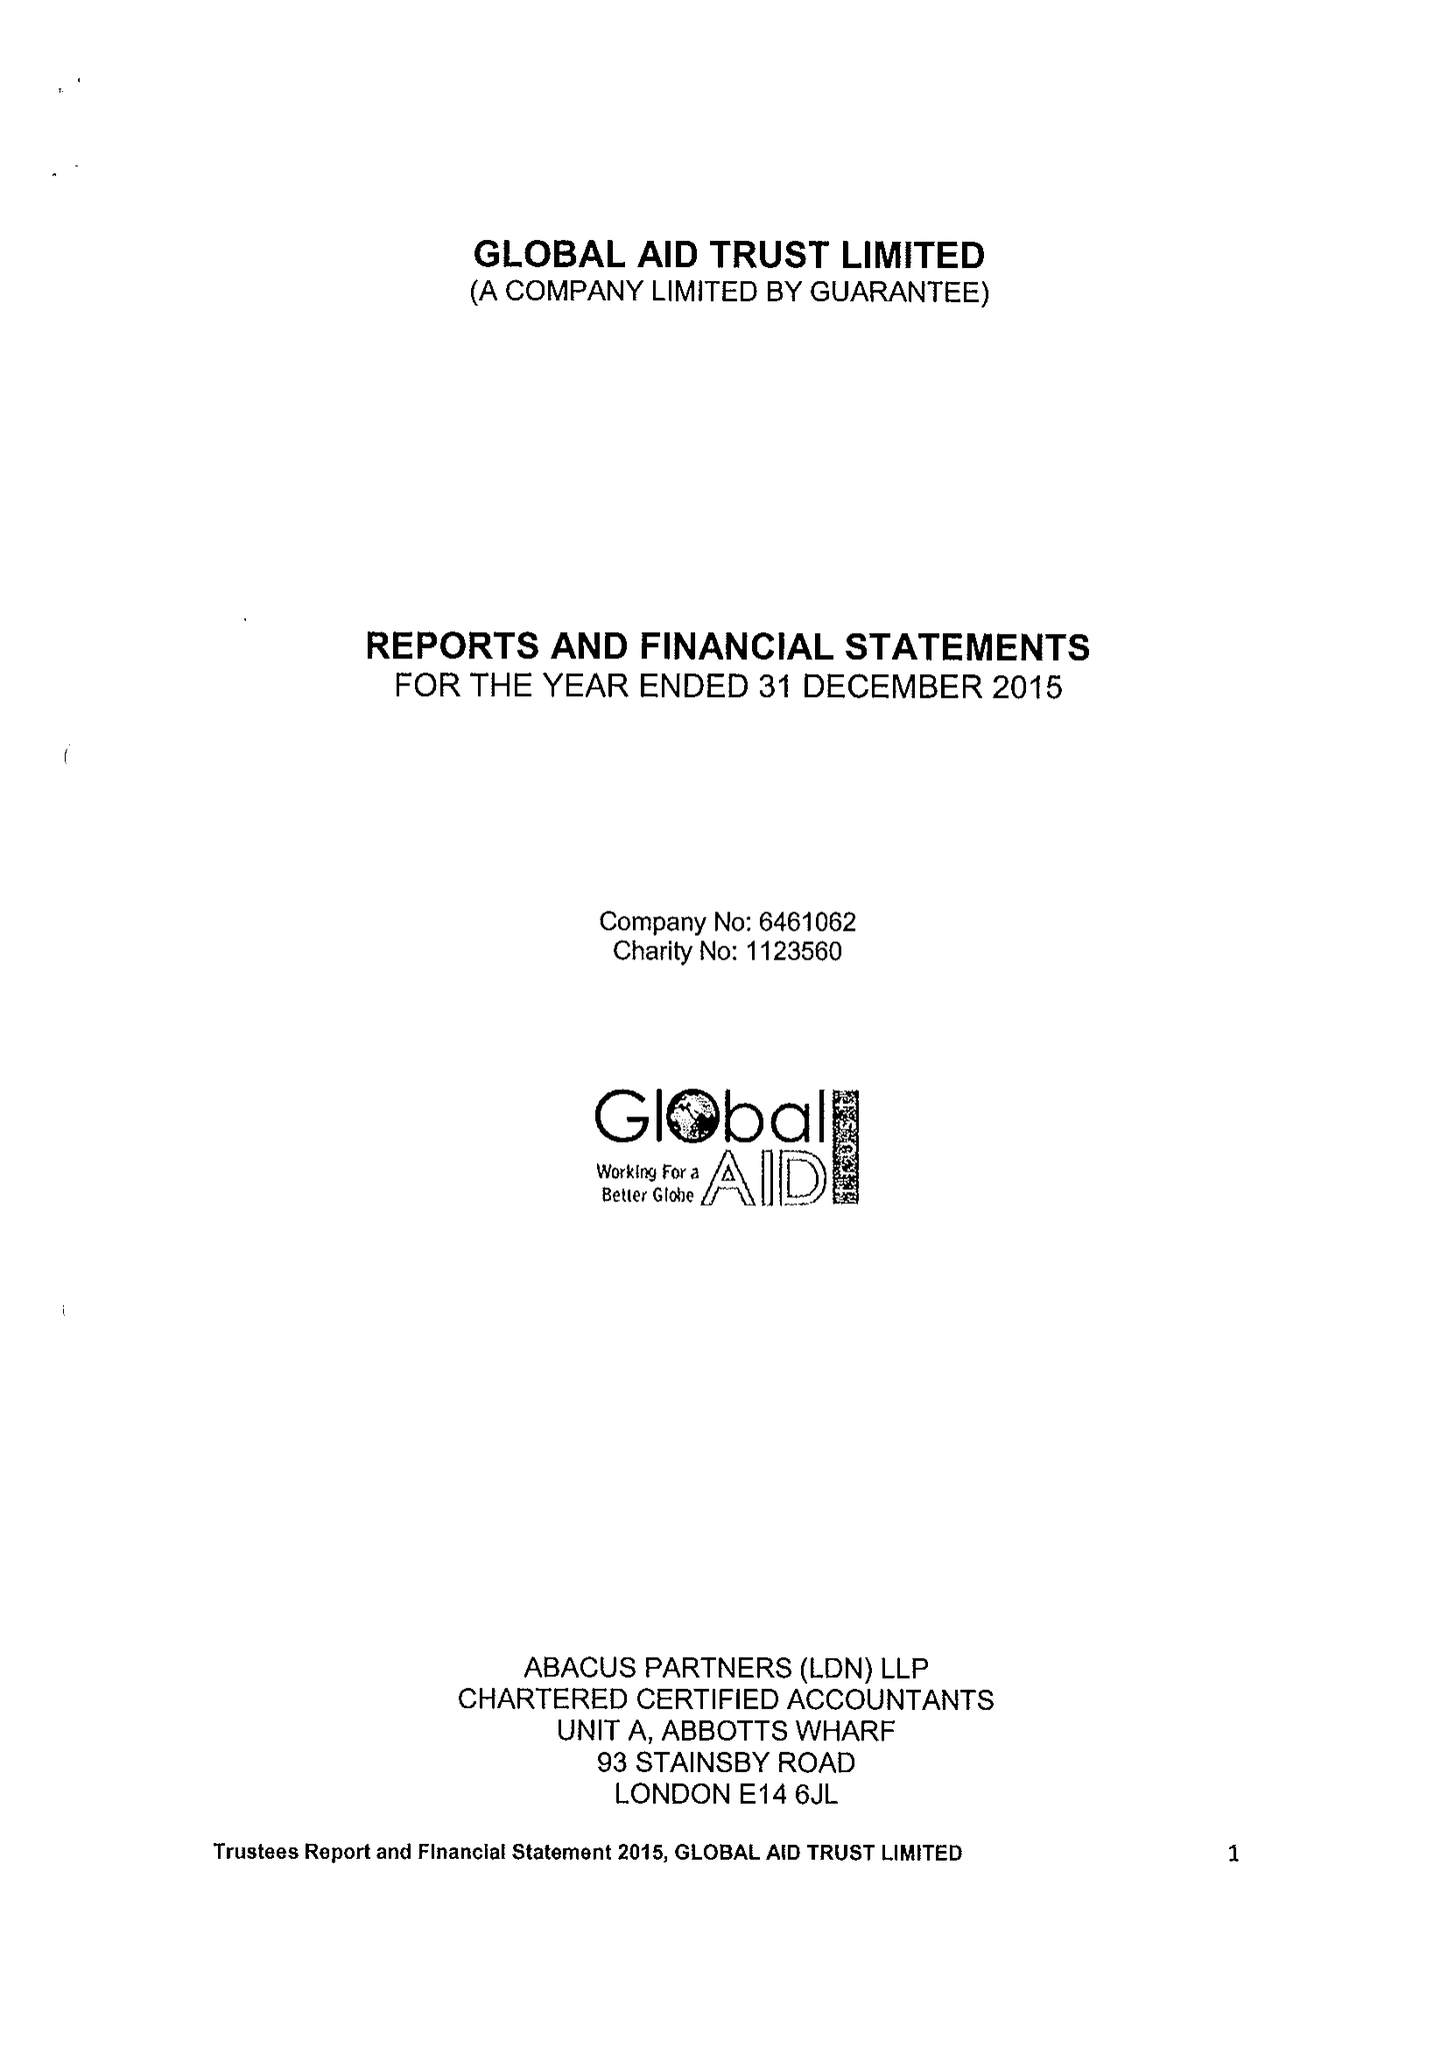What is the value for the spending_annually_in_british_pounds?
Answer the question using a single word or phrase. 346171.00 